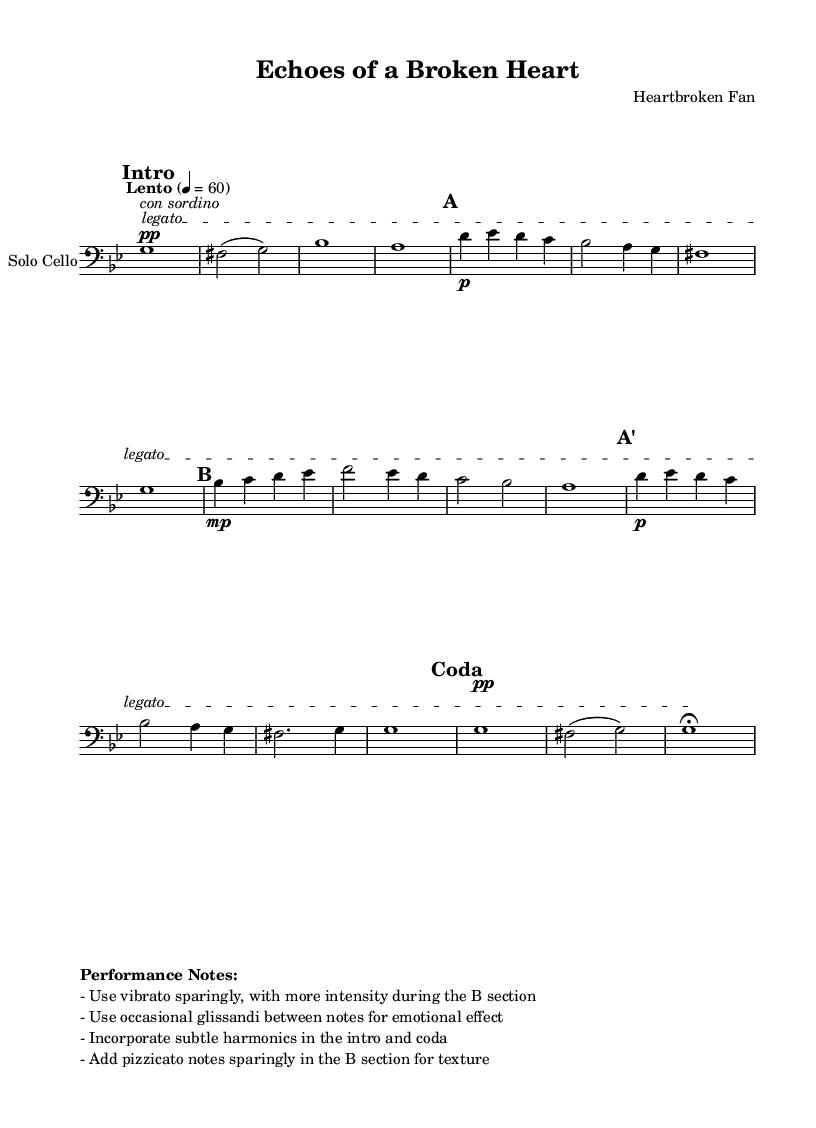What is the key signature of this music? The key signature is G minor, which contains two flats (B flat and E flat). This can be determined from the notation at the beginning of the staff that indicates the key.
Answer: G minor What is the time signature of this music? The time signature is 4/4, as indicated at the beginning of the score. It shows that there are four beats in each measure and a quarter note gets one beat.
Answer: 4/4 What is the tempo marking? The tempo marking is "Lento", which indicates a slow pace. The metronome indication of quarter note = 60 also reinforces this tempo marking.
Answer: Lento What dynamic marking is indicated at the beginning of the piece? The dynamic marking at the beginning of the piece is "pp", which stands for pianissimo, indicating very soft playing. This is indicated right before the first note.
Answer: pp In which section is vibrato suggested to be used sparingly? Vibrato is suggested to be used sparingly during the introduction; the performance notes indicate to use it more intensely during the B section. The performance notes specify this distinction clearly.
Answer: Intro How does the Coda differ from Section A? The Coda is marked by a return to a similar theme but concludes the piece with a fermata and a softer dynamic (pp), while Section A develops the primary theme without a fermata. The handling of dynamics and the inclusion of a fermata are distinguishing features.
Answer: Coda What texture is suggested during the B section? The performance notes suggest incorporating pizzicato notes sparingly in the B section, which adds a different texture to the music. This note specifies a specific technique to enrich the musical experience.
Answer: Pizzicato 